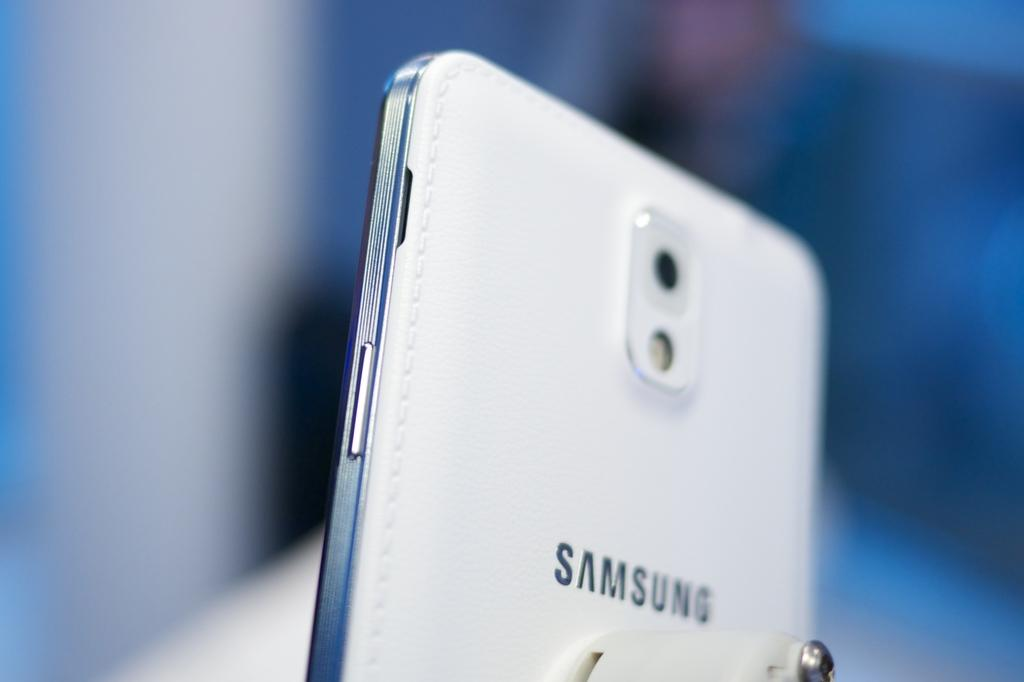<image>
Summarize the visual content of the image. A white Samsung phone is held at an angle so that the slim feature of the phone is recognizable. 